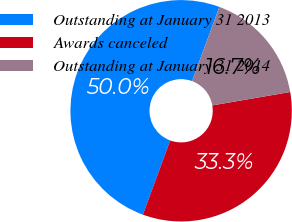Convert chart. <chart><loc_0><loc_0><loc_500><loc_500><pie_chart><fcel>Outstanding at January 31 2013<fcel>Awards canceled<fcel>Outstanding at January 31 2014<nl><fcel>50.0%<fcel>33.33%<fcel>16.67%<nl></chart> 